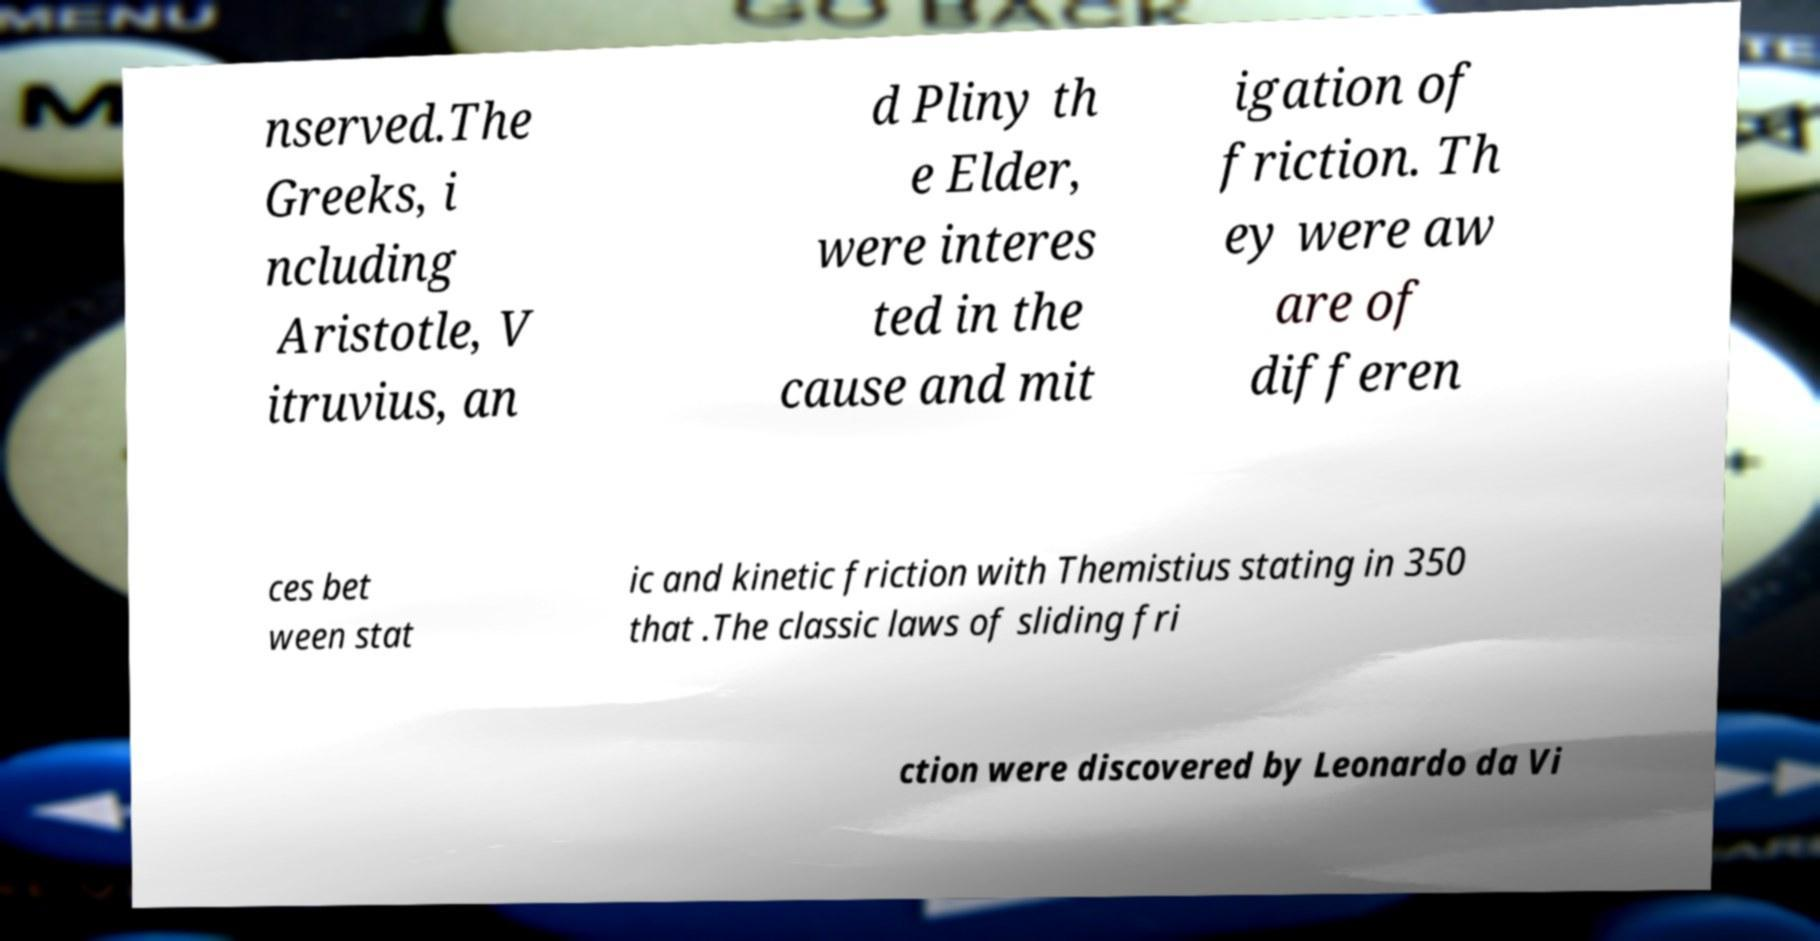Could you extract and type out the text from this image? nserved.The Greeks, i ncluding Aristotle, V itruvius, an d Pliny th e Elder, were interes ted in the cause and mit igation of friction. Th ey were aw are of differen ces bet ween stat ic and kinetic friction with Themistius stating in 350 that .The classic laws of sliding fri ction were discovered by Leonardo da Vi 